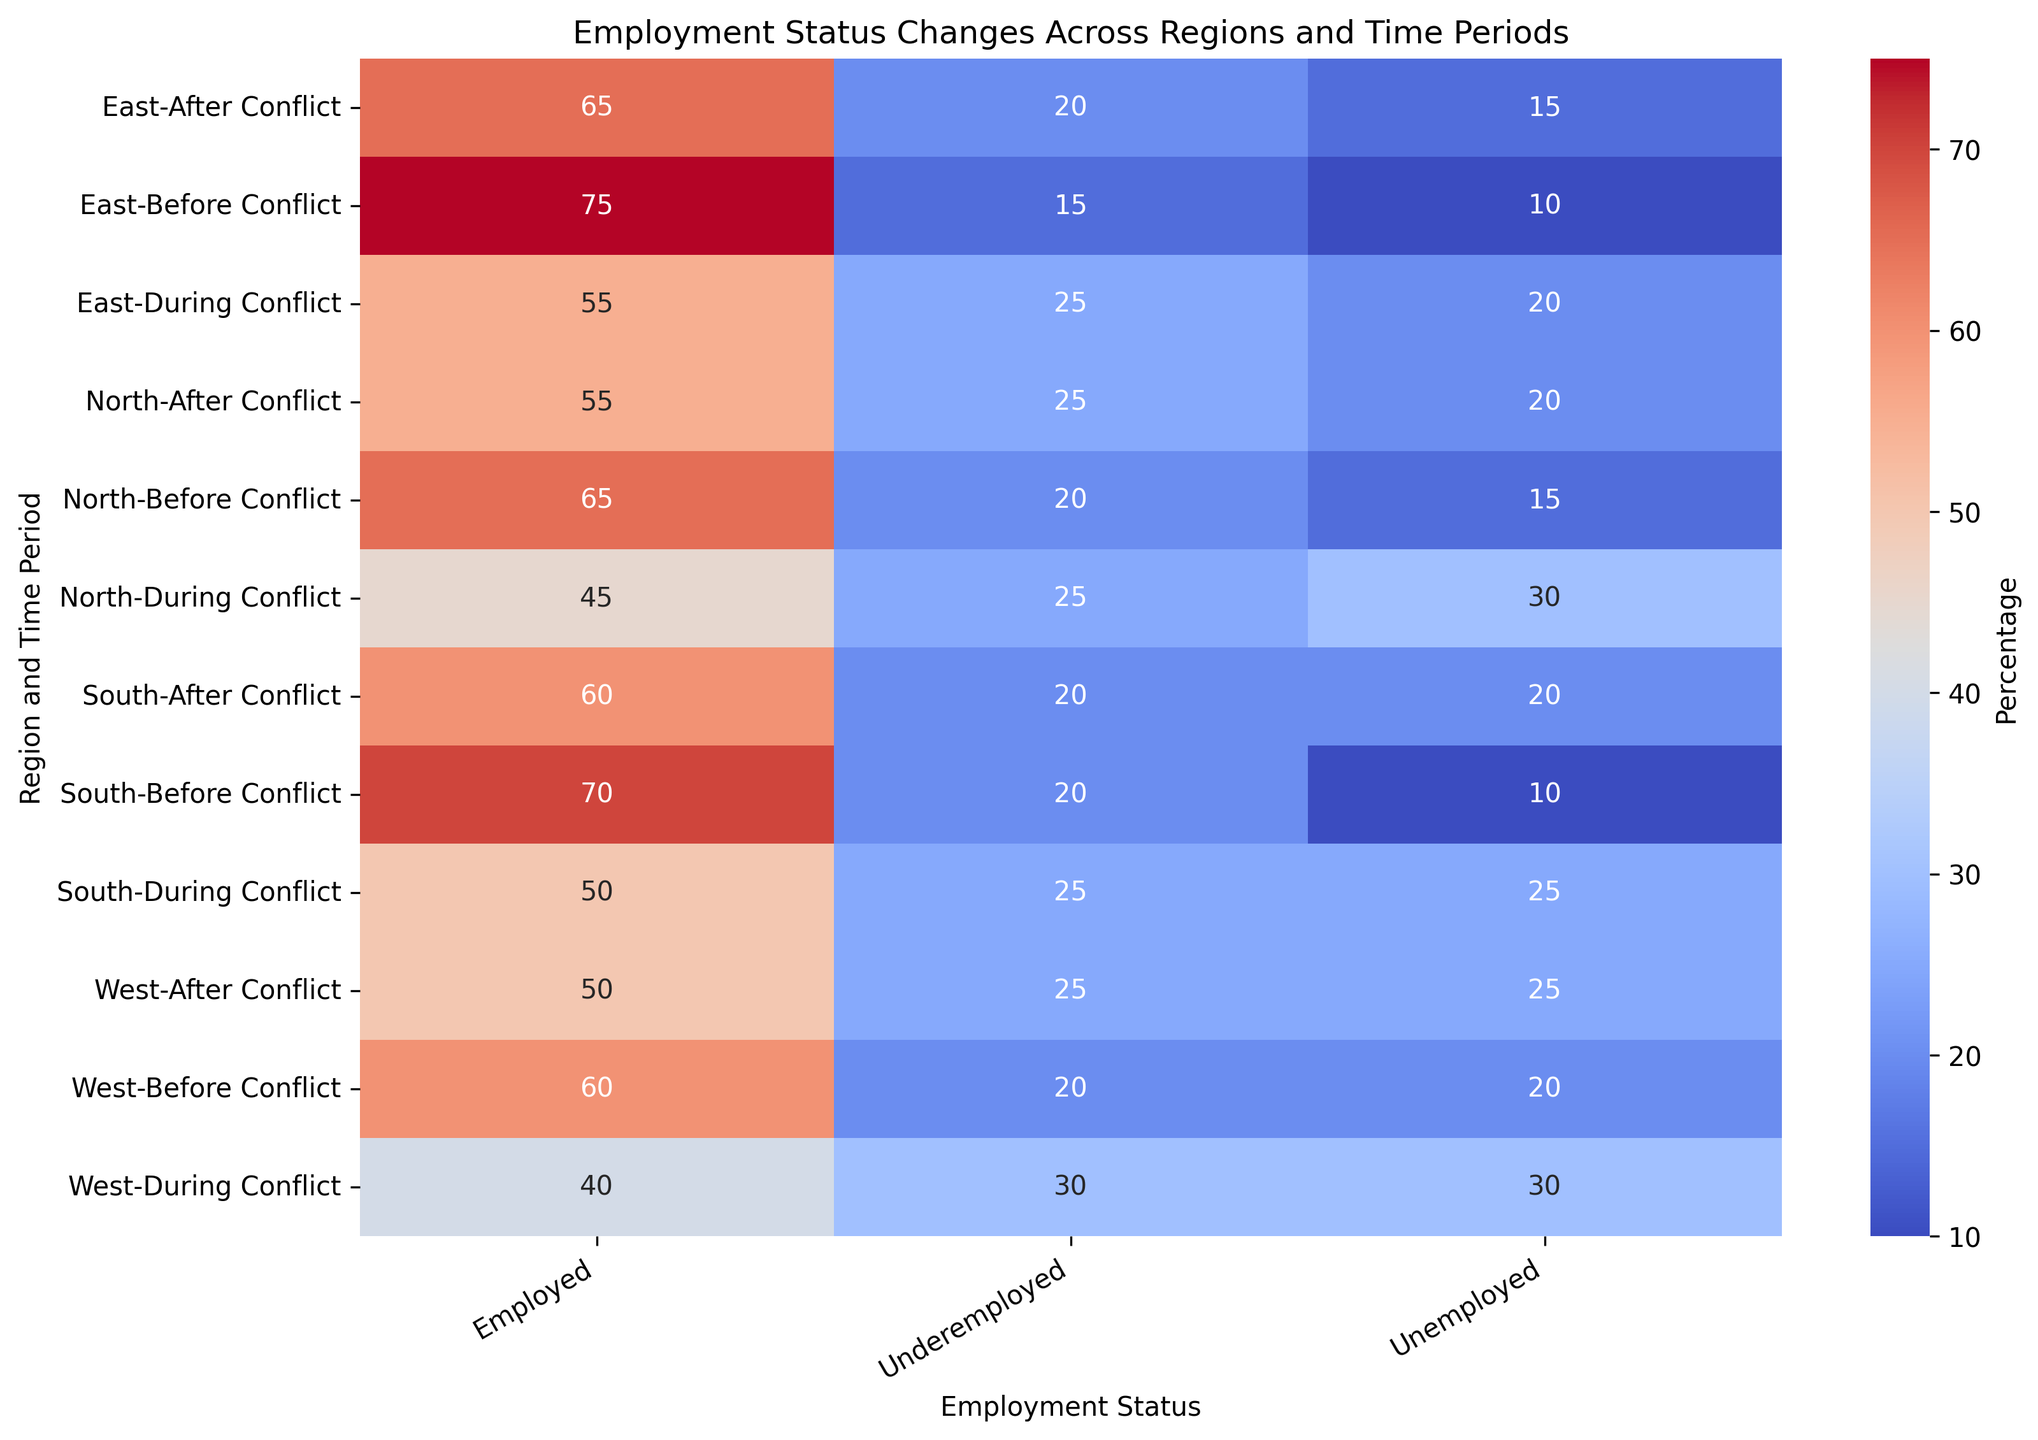What's the trend in employment rates in the North region across different time periods? The employment rate in the North decreased from 65% before the conflict to 45% during the conflict, then increased to 55% after the conflict. Observe the data values for North under 'Employed' for the Before, During, and After Conflict periods.
Answer: Decreased, then increased Which region had the highest unemployment rate during the conflict? During the conflict, the West region had the highest unemployment rate at 30%. Look at the values under 'Unemployed' for all regions during the conflict period.
Answer: West What is the difference in the underemployment rates in the East region before and after the conflict? In the East region, the underemployment rates were 15% before the conflict and 20% after it. The difference is calculated as 20% - 15%.
Answer: 5% Which region showed the most significant change in employment rates from before to during the conflict? The North region had the most significant change, with employment rates dropping from 65% to 45%, a decrease of 20%. Compare the 'Employed' percentages for all regions before and during the conflict, finding the largest difference.
Answer: North How does the South region's unemployment rate after the conflict compare to the North's during the conflict? The South's unemployment rate after the conflict is 20%, while the North's during the conflict is 30%. The North's rate was higher.
Answer: North is higher What is the average employment rate in the West region across all time periods? The employment rates in the West are 60% (Before), 40% (During), and 50% (After). The average is calculated as (60 + 40 + 50) / 3.
Answer: 50% Which time period had the highest level of underemployment overall? During the conflict, the underemployment rates were highest across most regions (25% in North, South, East, and 30% in West). Compare underemployment rates across all regions and periods, and note the highest occurrences.
Answer: During Conflict 